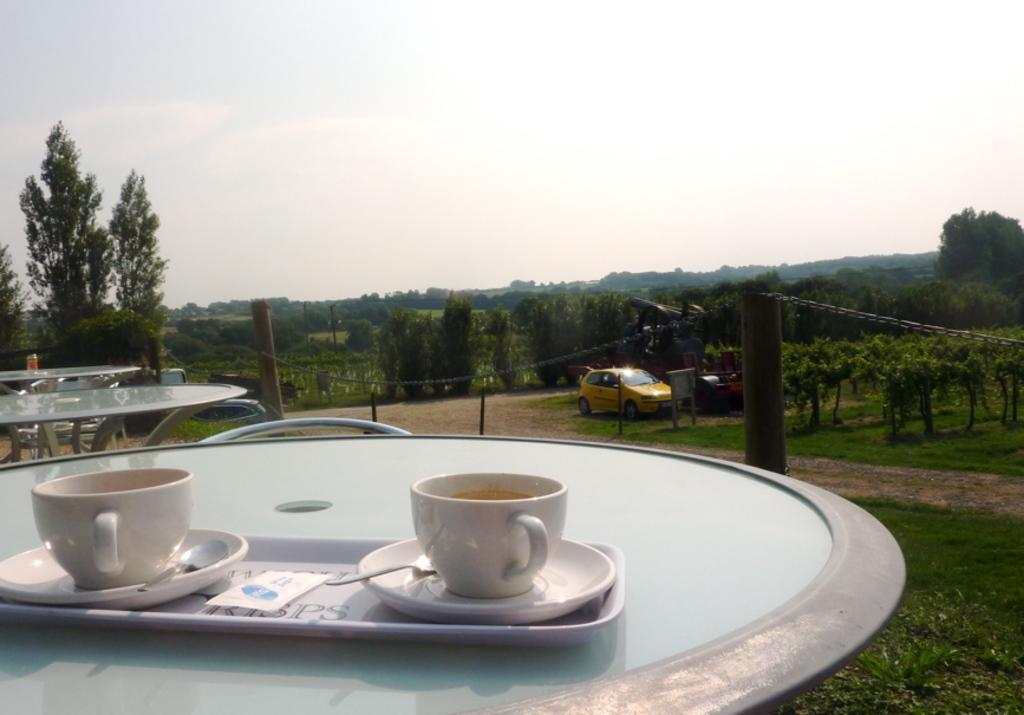What can be seen in the background of the image? There is a sky in the image. What type of vegetation is visible in the image? There are trees in the image. What type of furniture is present in the image? There are tables in the image. What items are on the tables? There are cups, saucers, spoons, and a tray on the tables. What color is the thumb on the tray in the image? There is no thumb present on the tray or in the image. How many bubbles are floating in the sky in the image? There are no bubbles visible in the sky or in the image. 